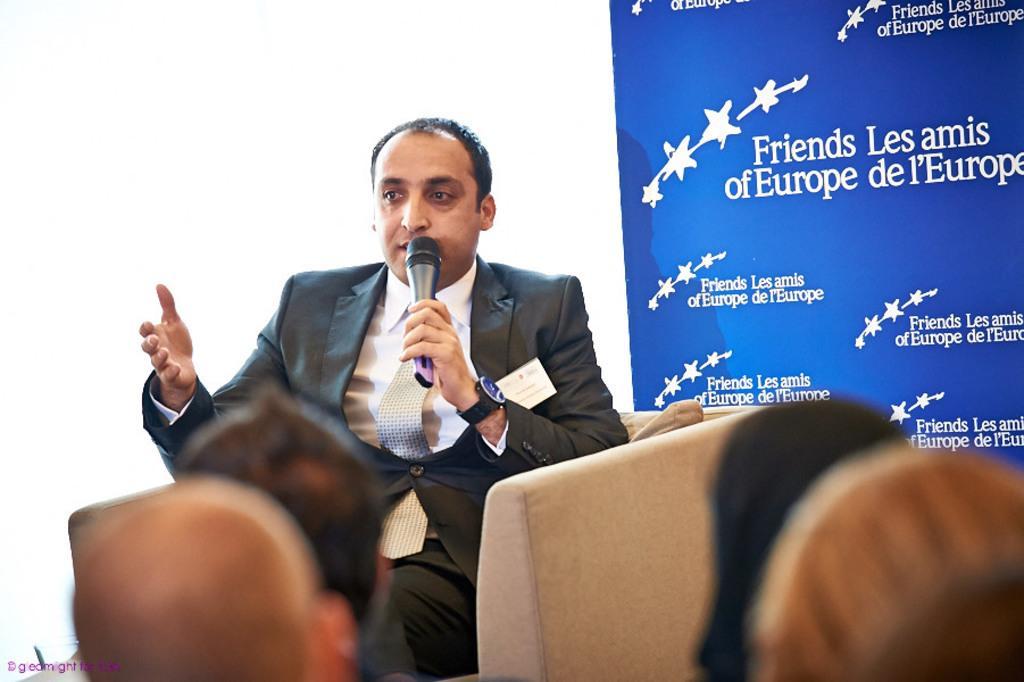In one or two sentences, can you explain what this image depicts? A man is sitting on the sofa and speaking into microphone. He wore coat, tie, shirt. On the right side there is a banner in blue color. 